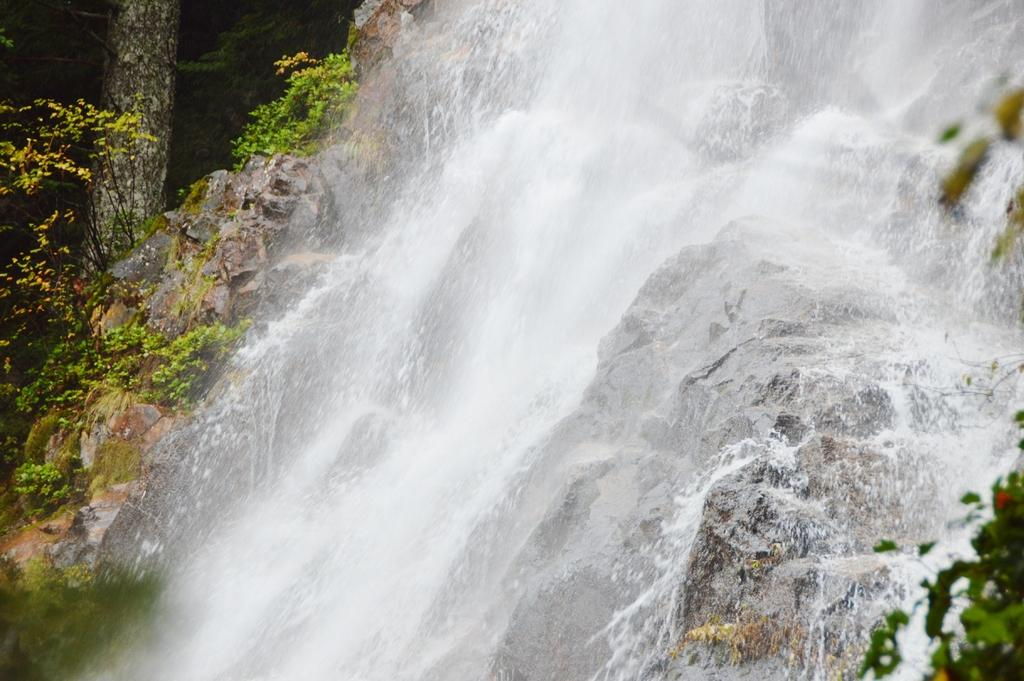What natural feature is the main subject of the image? There is a waterfall in the image. What can be seen at the base of the waterfall? Rocks are present at the bottom of the waterfall. What type of vegetation is visible in the background of the image? There are trees in the background of the image. How many ants can be seen crawling on the waterfall in the image? There are no ants visible in the image; it features a waterfall with rocks at the bottom and trees in the background. What type of bubble is floating near the waterfall in the image? There are no bubbles present in the image; it features a waterfall with rocks at the bottom and trees in the background. 